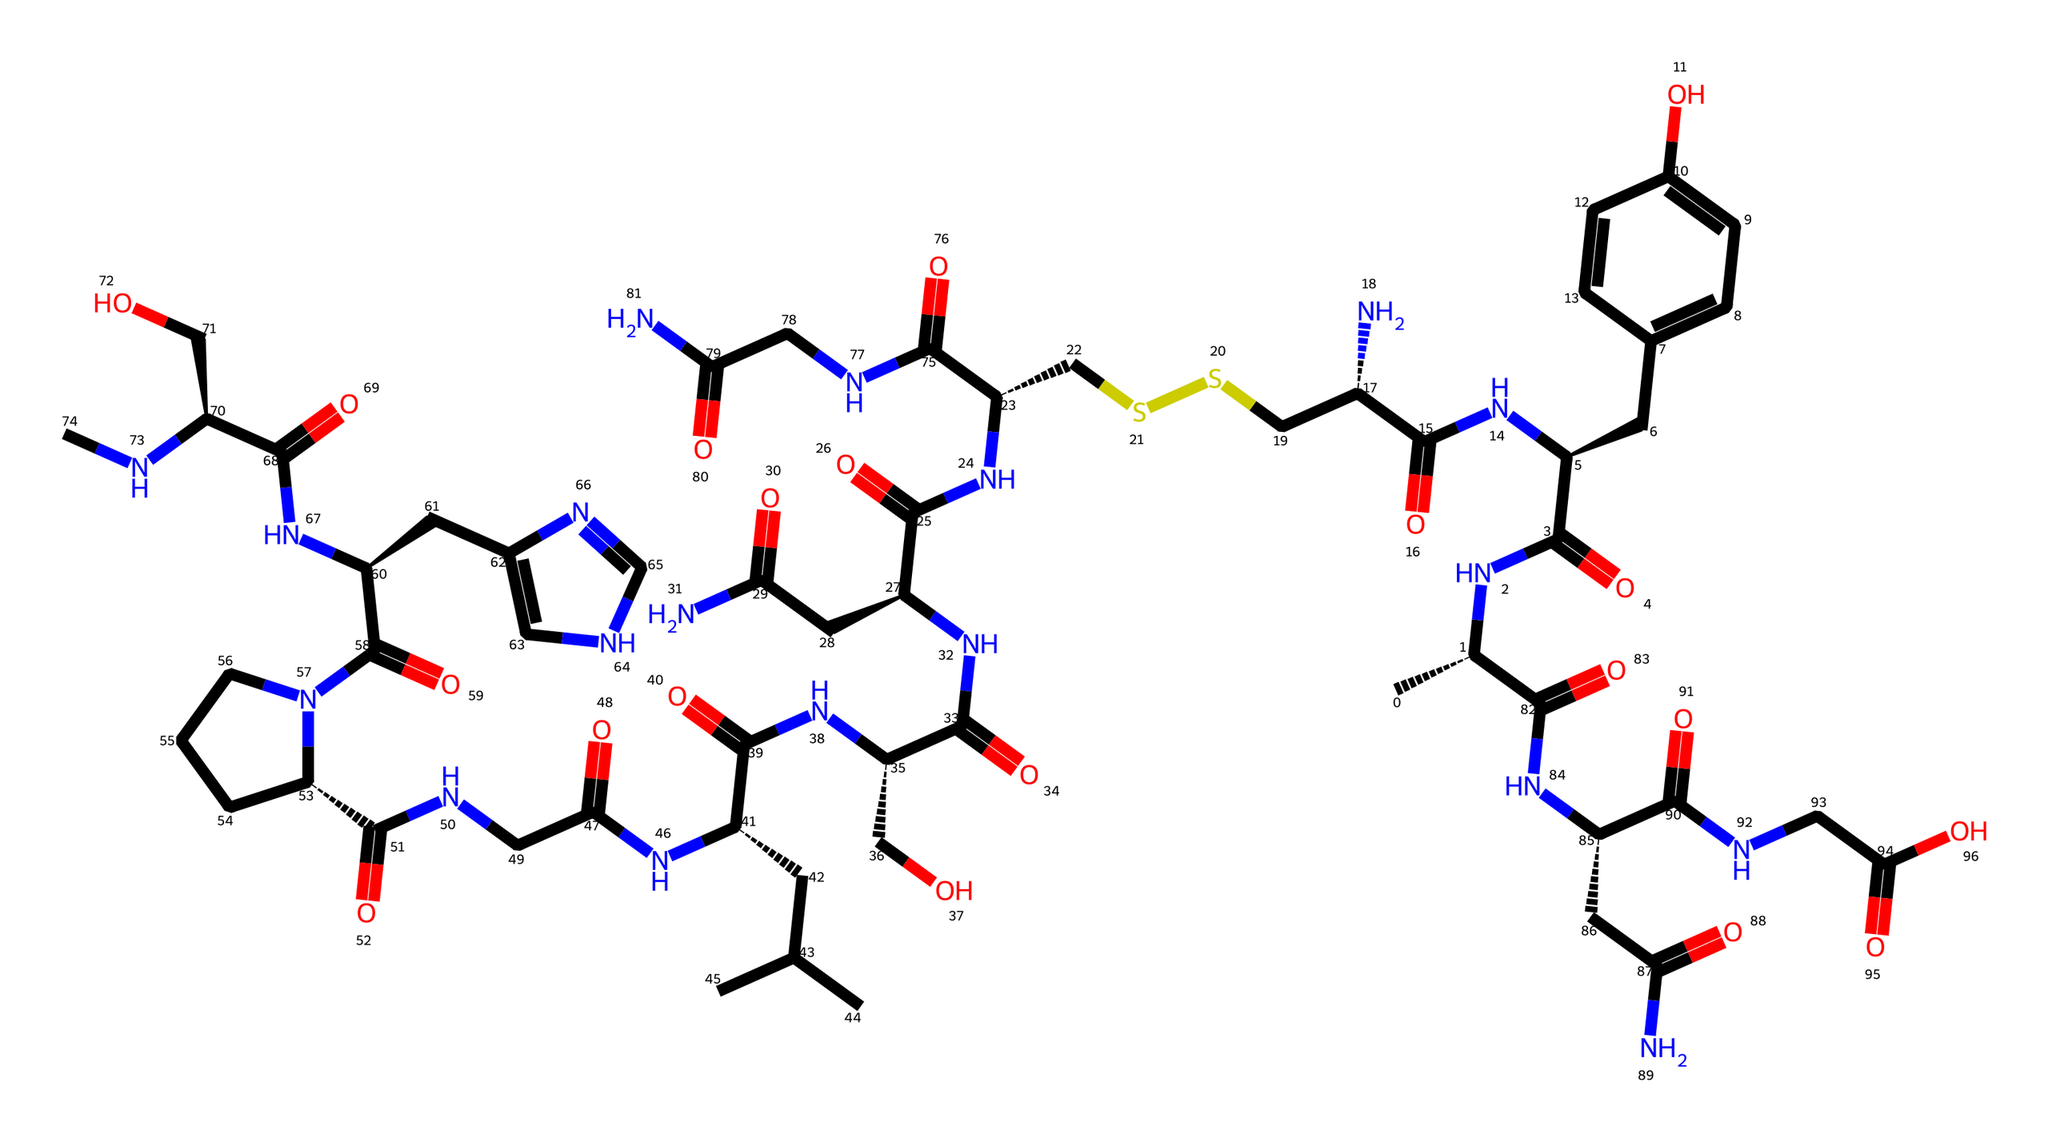What is the molecular formula of oxytocin based on its SMILES representation? The SMILES notation indicates the number of carbon (C), hydrogen (H), nitrogen (N), oxygen (O), and sulfur (S) atoms present. Counting these, oxytocin has a molecular formula of C43H66N12O12S2.
Answer: C43H66N12O12S2 How many nitrogen atoms are present in oxytocin? By analyzing the SMILES, we observe that the structure contains 12 instances of the letter "N," indicating that there are 12 nitrogen atoms.
Answer: 12 Is oxytocin a peptide or a steroid hormone? Oxytocin is made up of a chain of amino acids connected by peptide bonds, which classifies it as a peptide hormone rather than a steroid hormone.
Answer: peptide How many chiral centers does oxytocin have? In the SMILES, the "@" symbols indicate chiral centers. Reviewing the entire structure, oxytocin has 6 chiral centers as denoted by the "@" symbols in the representation.
Answer: 6 What functional groups are present in oxytocin? Analyzing the structure, we see multiple amide (NC(=O)), hydroxyl (O), and thioether (CSSC) functional groups present in the molecule. Based on this, we can confirm the presence of these functional groups.
Answer: amide, hydroxyl, thioether Which element in the structure contributes to disulfide bonding? The presence of sulfur atoms (S) in the SMILES representation indicates that oxytocin has potential disulfide bonds. Since there are two sulfur atoms, they can form disulfide linkages between cysteine residues.
Answer: sulfur What kind of biological activity is oxytocin associated with, based on its structure? The complex structure with multiple functional groups such as amides and a peptide backbone hints at its role in biological signaling, specifically in emotional bonding and maternal behaviors. Therefore, oxytocin is primarily associated with promoting social bonding and emotional connections.
Answer: bonding, social connection 